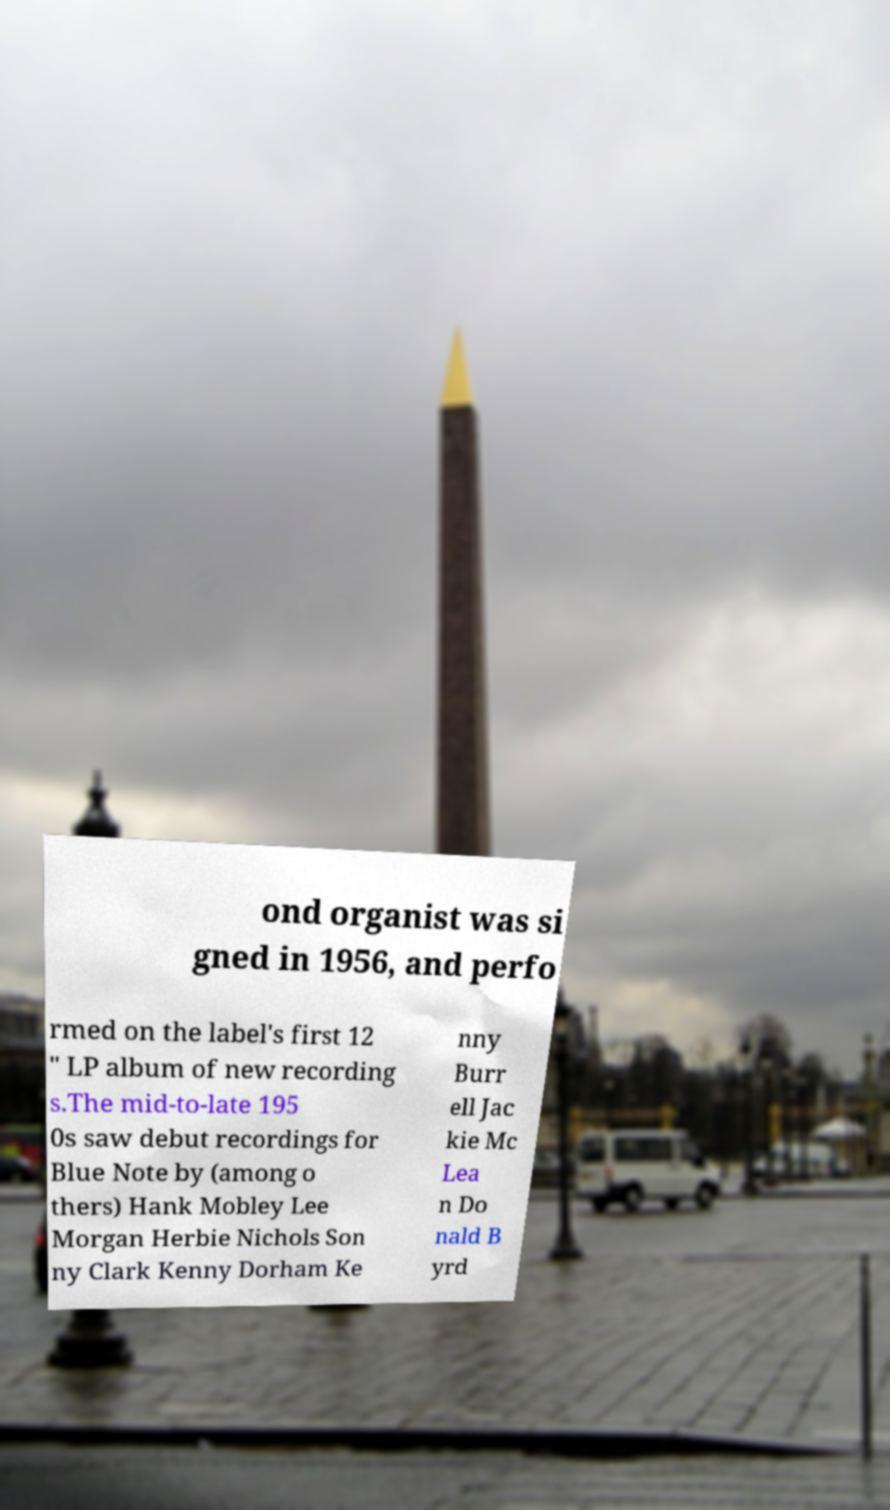Can you accurately transcribe the text from the provided image for me? ond organist was si gned in 1956, and perfo rmed on the label's first 12 " LP album of new recording s.The mid-to-late 195 0s saw debut recordings for Blue Note by (among o thers) Hank Mobley Lee Morgan Herbie Nichols Son ny Clark Kenny Dorham Ke nny Burr ell Jac kie Mc Lea n Do nald B yrd 